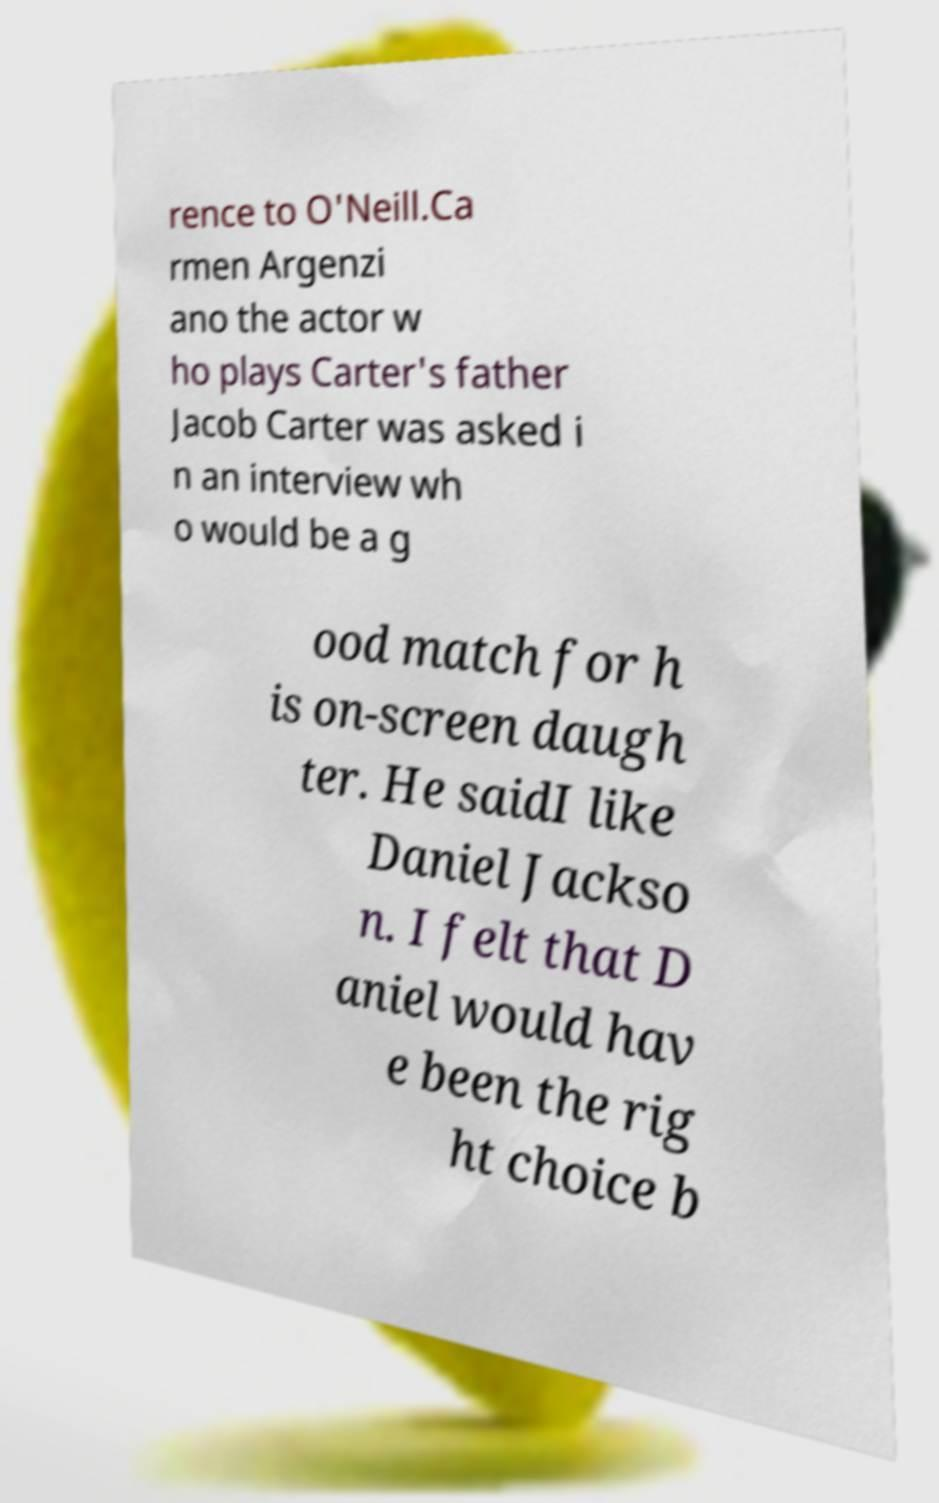Could you extract and type out the text from this image? rence to O'Neill.Ca rmen Argenzi ano the actor w ho plays Carter's father Jacob Carter was asked i n an interview wh o would be a g ood match for h is on-screen daugh ter. He saidI like Daniel Jackso n. I felt that D aniel would hav e been the rig ht choice b 